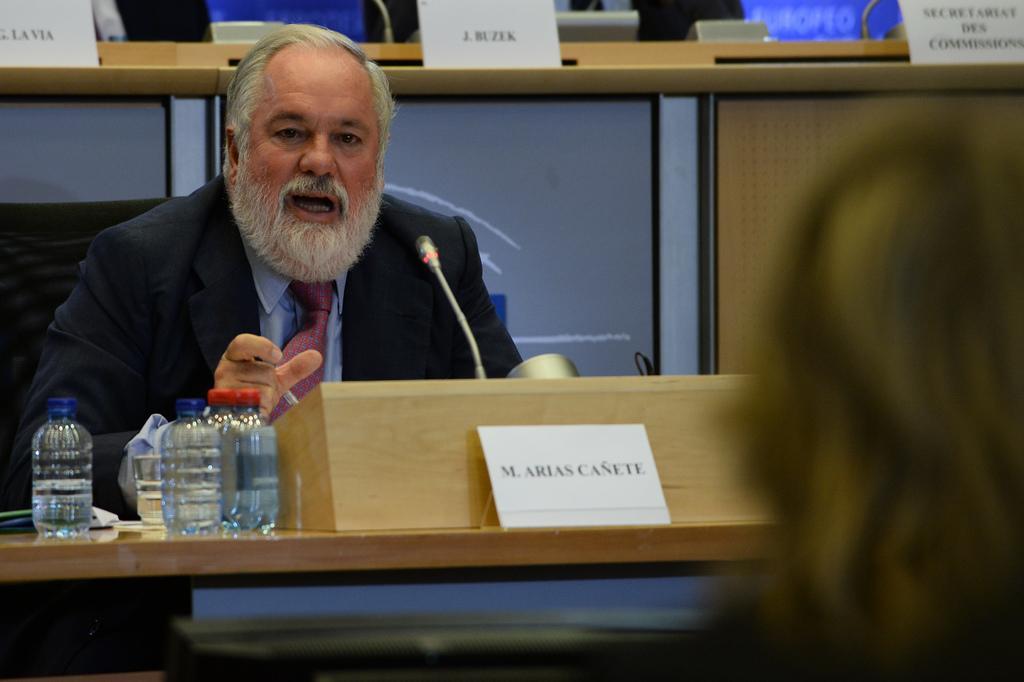Could you give a brief overview of what you see in this image? In this image I see a man who is wearing a suit and I see the table on which there is a mic, a name board and few bottles over here and I see a glass. In the background I see few more name boards and I see that it is blurred over here. 